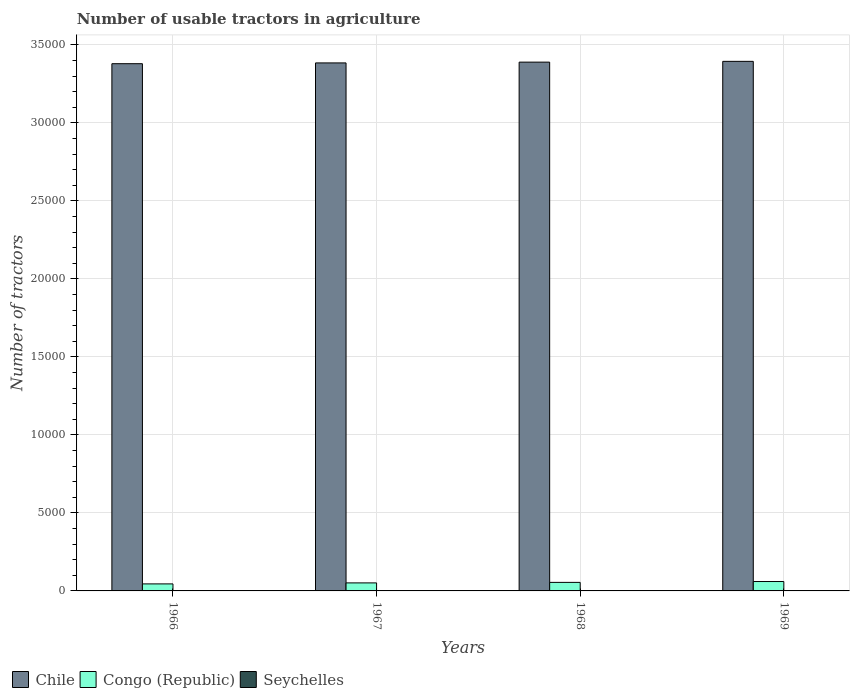How many groups of bars are there?
Offer a very short reply. 4. Are the number of bars on each tick of the X-axis equal?
Keep it short and to the point. Yes. What is the label of the 3rd group of bars from the left?
Provide a short and direct response. 1968. In how many cases, is the number of bars for a given year not equal to the number of legend labels?
Keep it short and to the point. 0. What is the number of usable tractors in agriculture in Congo (Republic) in 1966?
Provide a short and direct response. 450. Across all years, what is the maximum number of usable tractors in agriculture in Chile?
Provide a short and direct response. 3.40e+04. Across all years, what is the minimum number of usable tractors in agriculture in Congo (Republic)?
Your answer should be very brief. 450. In which year was the number of usable tractors in agriculture in Seychelles maximum?
Give a very brief answer. 1968. In which year was the number of usable tractors in agriculture in Congo (Republic) minimum?
Offer a terse response. 1966. What is the total number of usable tractors in agriculture in Congo (Republic) in the graph?
Give a very brief answer. 2113. What is the difference between the number of usable tractors in agriculture in Chile in 1967 and that in 1968?
Your answer should be very brief. -50. What is the difference between the number of usable tractors in agriculture in Congo (Republic) in 1968 and the number of usable tractors in agriculture in Chile in 1969?
Provide a succinct answer. -3.34e+04. What is the average number of usable tractors in agriculture in Seychelles per year?
Provide a short and direct response. 11.75. In the year 1966, what is the difference between the number of usable tractors in agriculture in Seychelles and number of usable tractors in agriculture in Congo (Republic)?
Provide a succinct answer. -441. In how many years, is the number of usable tractors in agriculture in Congo (Republic) greater than 9000?
Give a very brief answer. 0. Is the number of usable tractors in agriculture in Congo (Republic) in 1966 less than that in 1968?
Provide a succinct answer. Yes. Is the difference between the number of usable tractors in agriculture in Seychelles in 1967 and 1969 greater than the difference between the number of usable tractors in agriculture in Congo (Republic) in 1967 and 1969?
Make the answer very short. Yes. What is the difference between the highest and the lowest number of usable tractors in agriculture in Seychelles?
Offer a terse response. 5. Is the sum of the number of usable tractors in agriculture in Chile in 1967 and 1968 greater than the maximum number of usable tractors in agriculture in Congo (Republic) across all years?
Make the answer very short. Yes. What does the 2nd bar from the left in 1968 represents?
Give a very brief answer. Congo (Republic). How many bars are there?
Provide a short and direct response. 12. What is the difference between two consecutive major ticks on the Y-axis?
Your response must be concise. 5000. Does the graph contain grids?
Ensure brevity in your answer.  Yes. Where does the legend appear in the graph?
Your response must be concise. Bottom left. What is the title of the graph?
Provide a succinct answer. Number of usable tractors in agriculture. What is the label or title of the X-axis?
Your answer should be very brief. Years. What is the label or title of the Y-axis?
Provide a succinct answer. Number of tractors. What is the Number of tractors in Chile in 1966?
Make the answer very short. 3.38e+04. What is the Number of tractors of Congo (Republic) in 1966?
Your response must be concise. 450. What is the Number of tractors in Seychelles in 1966?
Provide a succinct answer. 9. What is the Number of tractors of Chile in 1967?
Keep it short and to the point. 3.38e+04. What is the Number of tractors in Congo (Republic) in 1967?
Offer a very short reply. 514. What is the Number of tractors in Seychelles in 1967?
Offer a terse response. 12. What is the Number of tractors in Chile in 1968?
Your answer should be compact. 3.39e+04. What is the Number of tractors of Congo (Republic) in 1968?
Offer a terse response. 547. What is the Number of tractors in Seychelles in 1968?
Your answer should be compact. 14. What is the Number of tractors of Chile in 1969?
Provide a succinct answer. 3.40e+04. What is the Number of tractors in Congo (Republic) in 1969?
Offer a terse response. 602. What is the Number of tractors of Seychelles in 1969?
Your response must be concise. 12. Across all years, what is the maximum Number of tractors of Chile?
Ensure brevity in your answer.  3.40e+04. Across all years, what is the maximum Number of tractors of Congo (Republic)?
Keep it short and to the point. 602. Across all years, what is the maximum Number of tractors in Seychelles?
Your response must be concise. 14. Across all years, what is the minimum Number of tractors of Chile?
Provide a succinct answer. 3.38e+04. Across all years, what is the minimum Number of tractors in Congo (Republic)?
Offer a terse response. 450. What is the total Number of tractors of Chile in the graph?
Give a very brief answer. 1.36e+05. What is the total Number of tractors in Congo (Republic) in the graph?
Your answer should be very brief. 2113. What is the difference between the Number of tractors of Chile in 1966 and that in 1967?
Provide a succinct answer. -50. What is the difference between the Number of tractors of Congo (Republic) in 1966 and that in 1967?
Your answer should be very brief. -64. What is the difference between the Number of tractors of Seychelles in 1966 and that in 1967?
Your answer should be very brief. -3. What is the difference between the Number of tractors in Chile in 1966 and that in 1968?
Make the answer very short. -100. What is the difference between the Number of tractors of Congo (Republic) in 1966 and that in 1968?
Provide a succinct answer. -97. What is the difference between the Number of tractors of Chile in 1966 and that in 1969?
Keep it short and to the point. -150. What is the difference between the Number of tractors in Congo (Republic) in 1966 and that in 1969?
Provide a short and direct response. -152. What is the difference between the Number of tractors in Chile in 1967 and that in 1968?
Keep it short and to the point. -50. What is the difference between the Number of tractors in Congo (Republic) in 1967 and that in 1968?
Make the answer very short. -33. What is the difference between the Number of tractors of Chile in 1967 and that in 1969?
Ensure brevity in your answer.  -100. What is the difference between the Number of tractors in Congo (Republic) in 1967 and that in 1969?
Make the answer very short. -88. What is the difference between the Number of tractors of Chile in 1968 and that in 1969?
Make the answer very short. -50. What is the difference between the Number of tractors in Congo (Republic) in 1968 and that in 1969?
Offer a terse response. -55. What is the difference between the Number of tractors in Chile in 1966 and the Number of tractors in Congo (Republic) in 1967?
Ensure brevity in your answer.  3.33e+04. What is the difference between the Number of tractors of Chile in 1966 and the Number of tractors of Seychelles in 1967?
Ensure brevity in your answer.  3.38e+04. What is the difference between the Number of tractors in Congo (Republic) in 1966 and the Number of tractors in Seychelles in 1967?
Your response must be concise. 438. What is the difference between the Number of tractors of Chile in 1966 and the Number of tractors of Congo (Republic) in 1968?
Keep it short and to the point. 3.33e+04. What is the difference between the Number of tractors in Chile in 1966 and the Number of tractors in Seychelles in 1968?
Keep it short and to the point. 3.38e+04. What is the difference between the Number of tractors in Congo (Republic) in 1966 and the Number of tractors in Seychelles in 1968?
Provide a succinct answer. 436. What is the difference between the Number of tractors in Chile in 1966 and the Number of tractors in Congo (Republic) in 1969?
Keep it short and to the point. 3.32e+04. What is the difference between the Number of tractors of Chile in 1966 and the Number of tractors of Seychelles in 1969?
Make the answer very short. 3.38e+04. What is the difference between the Number of tractors of Congo (Republic) in 1966 and the Number of tractors of Seychelles in 1969?
Make the answer very short. 438. What is the difference between the Number of tractors in Chile in 1967 and the Number of tractors in Congo (Republic) in 1968?
Provide a short and direct response. 3.33e+04. What is the difference between the Number of tractors of Chile in 1967 and the Number of tractors of Seychelles in 1968?
Your answer should be compact. 3.38e+04. What is the difference between the Number of tractors of Chile in 1967 and the Number of tractors of Congo (Republic) in 1969?
Make the answer very short. 3.32e+04. What is the difference between the Number of tractors in Chile in 1967 and the Number of tractors in Seychelles in 1969?
Ensure brevity in your answer.  3.38e+04. What is the difference between the Number of tractors of Congo (Republic) in 1967 and the Number of tractors of Seychelles in 1969?
Provide a short and direct response. 502. What is the difference between the Number of tractors of Chile in 1968 and the Number of tractors of Congo (Republic) in 1969?
Keep it short and to the point. 3.33e+04. What is the difference between the Number of tractors in Chile in 1968 and the Number of tractors in Seychelles in 1969?
Your answer should be very brief. 3.39e+04. What is the difference between the Number of tractors of Congo (Republic) in 1968 and the Number of tractors of Seychelles in 1969?
Ensure brevity in your answer.  535. What is the average Number of tractors of Chile per year?
Give a very brief answer. 3.39e+04. What is the average Number of tractors in Congo (Republic) per year?
Keep it short and to the point. 528.25. What is the average Number of tractors in Seychelles per year?
Make the answer very short. 11.75. In the year 1966, what is the difference between the Number of tractors in Chile and Number of tractors in Congo (Republic)?
Ensure brevity in your answer.  3.34e+04. In the year 1966, what is the difference between the Number of tractors of Chile and Number of tractors of Seychelles?
Give a very brief answer. 3.38e+04. In the year 1966, what is the difference between the Number of tractors in Congo (Republic) and Number of tractors in Seychelles?
Your answer should be compact. 441. In the year 1967, what is the difference between the Number of tractors in Chile and Number of tractors in Congo (Republic)?
Offer a terse response. 3.33e+04. In the year 1967, what is the difference between the Number of tractors of Chile and Number of tractors of Seychelles?
Provide a succinct answer. 3.38e+04. In the year 1967, what is the difference between the Number of tractors of Congo (Republic) and Number of tractors of Seychelles?
Provide a short and direct response. 502. In the year 1968, what is the difference between the Number of tractors in Chile and Number of tractors in Congo (Republic)?
Ensure brevity in your answer.  3.34e+04. In the year 1968, what is the difference between the Number of tractors in Chile and Number of tractors in Seychelles?
Offer a terse response. 3.39e+04. In the year 1968, what is the difference between the Number of tractors of Congo (Republic) and Number of tractors of Seychelles?
Offer a terse response. 533. In the year 1969, what is the difference between the Number of tractors in Chile and Number of tractors in Congo (Republic)?
Keep it short and to the point. 3.33e+04. In the year 1969, what is the difference between the Number of tractors of Chile and Number of tractors of Seychelles?
Your response must be concise. 3.39e+04. In the year 1969, what is the difference between the Number of tractors in Congo (Republic) and Number of tractors in Seychelles?
Keep it short and to the point. 590. What is the ratio of the Number of tractors in Chile in 1966 to that in 1967?
Provide a succinct answer. 1. What is the ratio of the Number of tractors in Congo (Republic) in 1966 to that in 1967?
Offer a very short reply. 0.88. What is the ratio of the Number of tractors of Congo (Republic) in 1966 to that in 1968?
Provide a short and direct response. 0.82. What is the ratio of the Number of tractors of Seychelles in 1966 to that in 1968?
Your answer should be very brief. 0.64. What is the ratio of the Number of tractors in Chile in 1966 to that in 1969?
Your response must be concise. 1. What is the ratio of the Number of tractors of Congo (Republic) in 1966 to that in 1969?
Your response must be concise. 0.75. What is the ratio of the Number of tractors of Chile in 1967 to that in 1968?
Give a very brief answer. 1. What is the ratio of the Number of tractors of Congo (Republic) in 1967 to that in 1968?
Keep it short and to the point. 0.94. What is the ratio of the Number of tractors in Congo (Republic) in 1967 to that in 1969?
Your answer should be compact. 0.85. What is the ratio of the Number of tractors in Seychelles in 1967 to that in 1969?
Your response must be concise. 1. What is the ratio of the Number of tractors in Chile in 1968 to that in 1969?
Your answer should be very brief. 1. What is the ratio of the Number of tractors of Congo (Republic) in 1968 to that in 1969?
Ensure brevity in your answer.  0.91. What is the ratio of the Number of tractors in Seychelles in 1968 to that in 1969?
Make the answer very short. 1.17. What is the difference between the highest and the second highest Number of tractors of Chile?
Your answer should be compact. 50. What is the difference between the highest and the second highest Number of tractors of Congo (Republic)?
Keep it short and to the point. 55. What is the difference between the highest and the lowest Number of tractors in Chile?
Your response must be concise. 150. What is the difference between the highest and the lowest Number of tractors of Congo (Republic)?
Offer a terse response. 152. What is the difference between the highest and the lowest Number of tractors in Seychelles?
Provide a succinct answer. 5. 